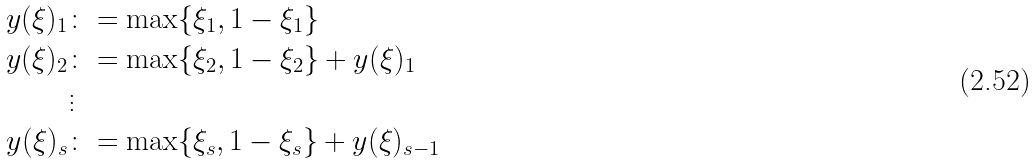<formula> <loc_0><loc_0><loc_500><loc_500>y ( \xi ) _ { 1 } & \colon = \max \{ \xi _ { 1 } , 1 - \xi _ { 1 } \} \\ y ( \xi ) _ { 2 } & \colon = \max \{ \xi _ { 2 } , 1 - \xi _ { 2 } \} + y ( \xi ) _ { 1 } \\ & \vdots \\ y ( \xi ) _ { s } & \colon = \max \{ \xi _ { s } , 1 - \xi _ { s } \} + y ( \xi ) _ { s - 1 }</formula> 